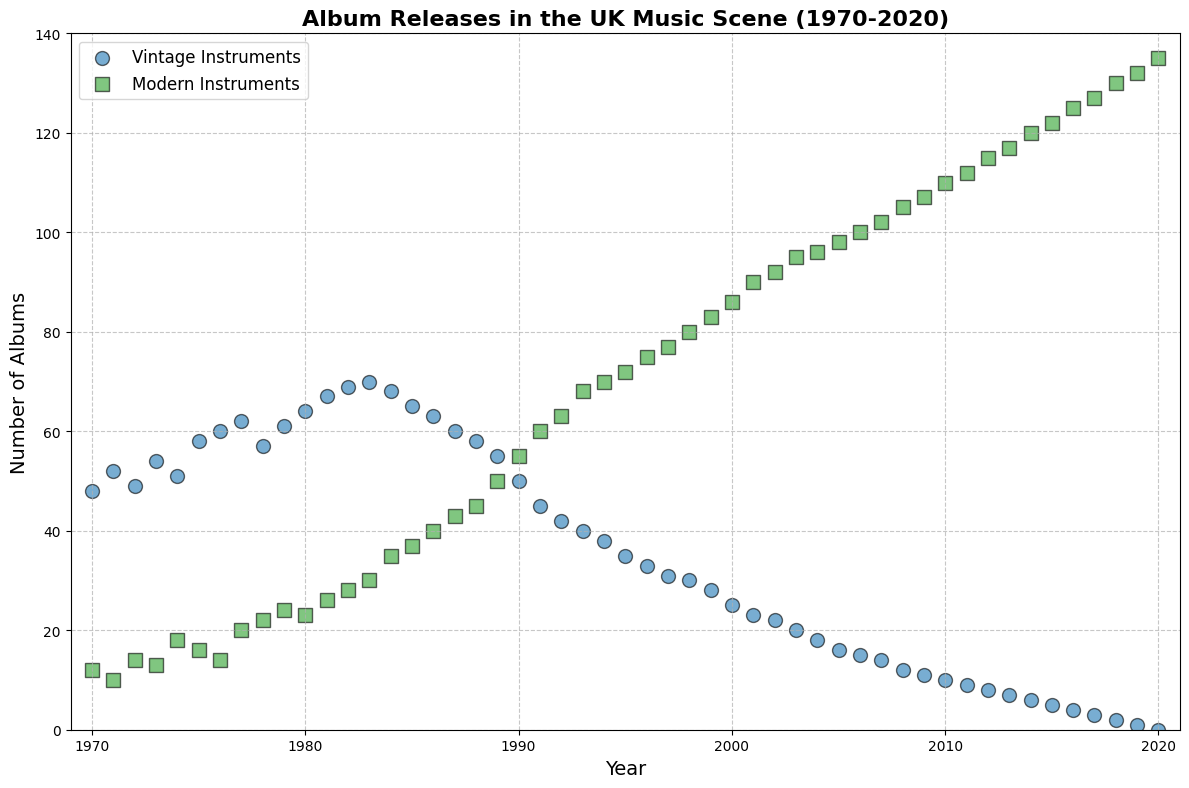What trends can be observed for the number of albums released with vintage instruments over the years? Initially, from 1970 to 1983, there is an increase in the number of album releases using vintage instruments. From 1984 onwards, there's a noticeable decline in the number of albums released using vintage instruments until it reaches zero in 2020.
Answer: Increase until 1983, then decrease until 2020 In which year does the number of albums released with modern instruments surpass those released with vintage instruments? The plot shows that vintage instruments were more popular until 1988 when albums with modern instruments start to catch up and eventually surpass those with vintage instruments in 1989.
Answer: 1989 How many more albums were released with vintage instruments compared to modern instruments in 1978? From the figure, in 1978, there were 57 albums with vintage instruments and 22 with modern instruments. The difference is 57 - 22.
Answer: 35 What is the trend in album releases using modern instruments from 1970 to 2020? The plot indicates an upward trend for albums released with modern instruments over the entire period from 1970 to 2020. The number of such albums increases steadily every year.
Answer: Increasing How many albums in total were released in 1980 (summing both vintage and modern)? According to the plot, in 1980, there were 64 albums with vintage instruments and 23 with modern instruments. The total is 64 + 23.
Answer: 87 When was the peak year for album releases with vintage instruments? By looking at the scatter plot for vintage instruments, the highest number of releases occurred in 1983.
Answer: 1983 By how much did the number of albums with vintage instruments decrease from 1982 to 1987? In 1982, there were 69 albums with vintage instruments, and in 1987, there were 60. The decrease is 69 - 60.
Answer: 9 How do the number of albums released in 1995 with each instrument type compare? The plot shows 35 albums were released with vintage instruments and 72 with modern instruments in 1995.
Answer: 72 modern, 35 vintage What is the ratio of albums released with modern instruments to those with vintage instruments in 2010? In 2010, there were 10 albums with vintage instruments and 110 with modern instruments. The ratio is 110 / 10.
Answer: 11:1 